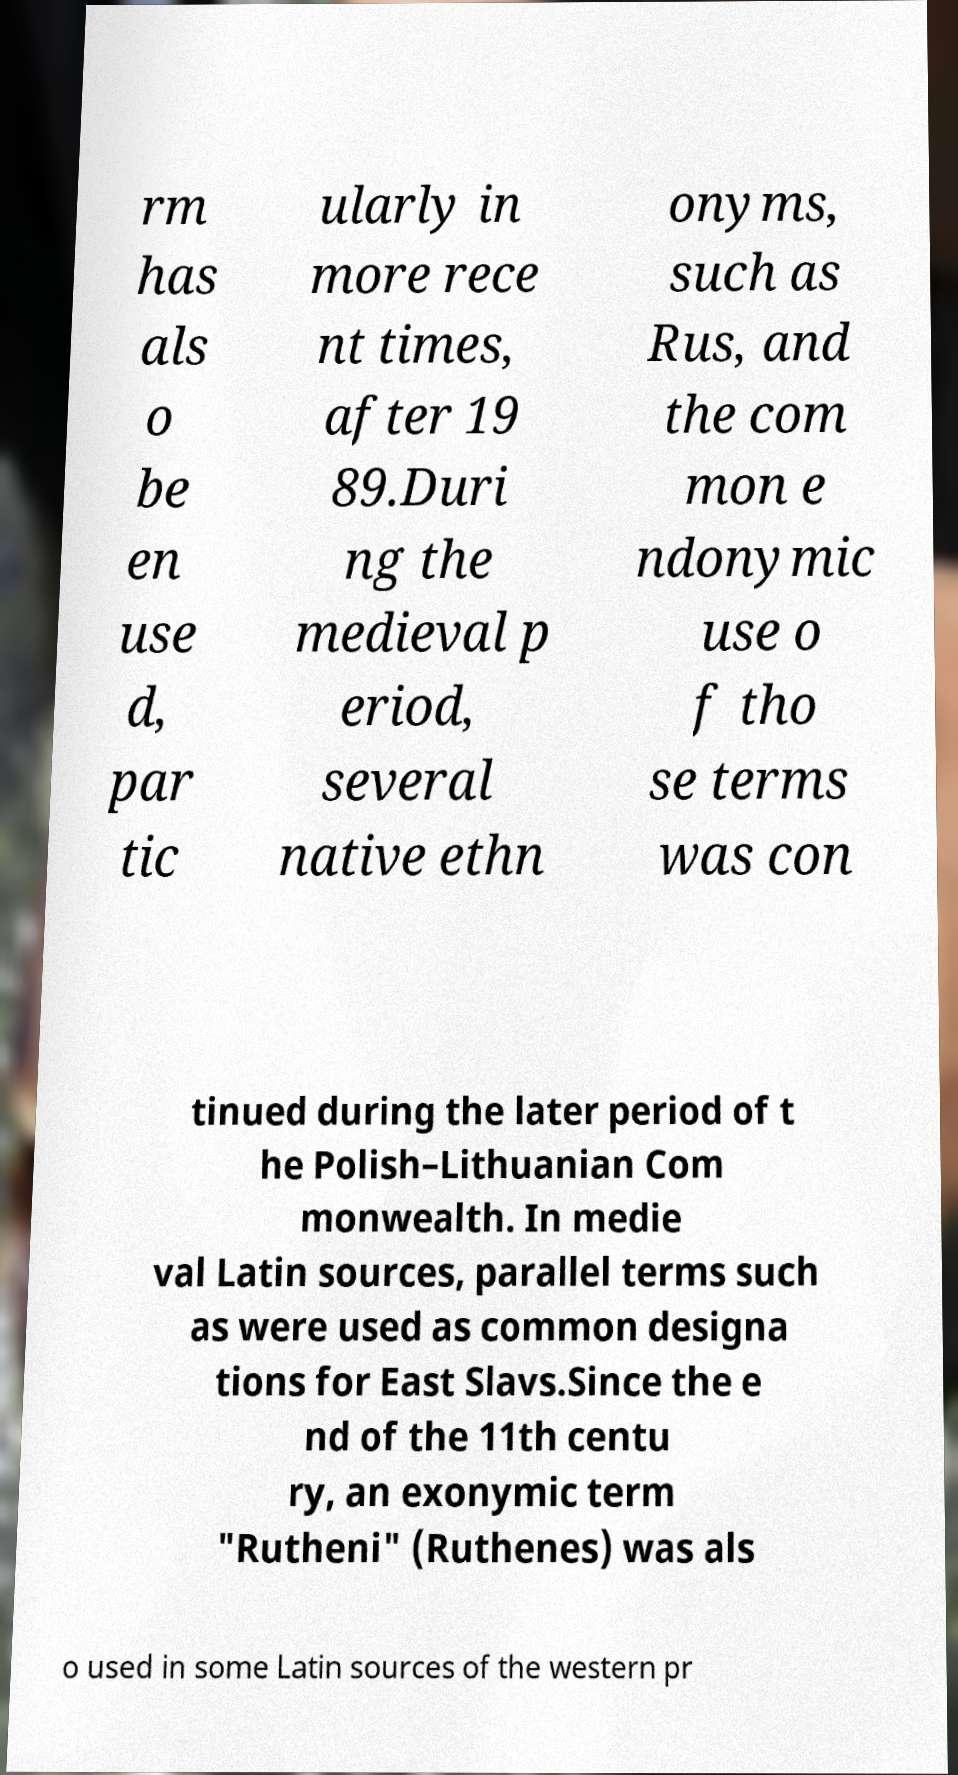There's text embedded in this image that I need extracted. Can you transcribe it verbatim? rm has als o be en use d, par tic ularly in more rece nt times, after 19 89.Duri ng the medieval p eriod, several native ethn onyms, such as Rus, and the com mon e ndonymic use o f tho se terms was con tinued during the later period of t he Polish–Lithuanian Com monwealth. In medie val Latin sources, parallel terms such as were used as common designa tions for East Slavs.Since the e nd of the 11th centu ry, an exonymic term "Rutheni" (Ruthenes) was als o used in some Latin sources of the western pr 